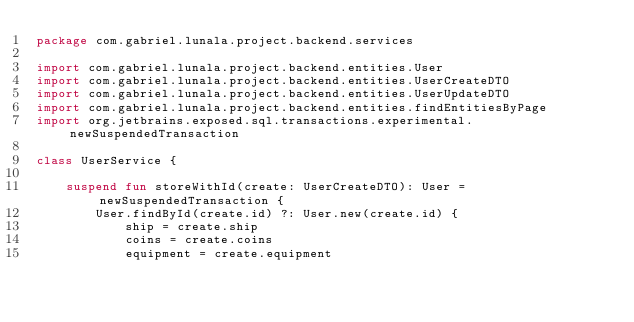Convert code to text. <code><loc_0><loc_0><loc_500><loc_500><_Kotlin_>package com.gabriel.lunala.project.backend.services

import com.gabriel.lunala.project.backend.entities.User
import com.gabriel.lunala.project.backend.entities.UserCreateDTO
import com.gabriel.lunala.project.backend.entities.UserUpdateDTO
import com.gabriel.lunala.project.backend.entities.findEntitiesByPage
import org.jetbrains.exposed.sql.transactions.experimental.newSuspendedTransaction

class UserService {

    suspend fun storeWithId(create: UserCreateDTO): User = newSuspendedTransaction {
        User.findById(create.id) ?: User.new(create.id) {
            ship = create.ship
            coins = create.coins
            equipment = create.equipment</code> 